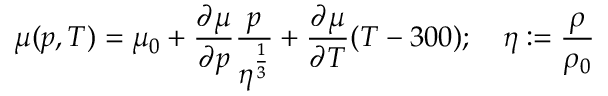<formula> <loc_0><loc_0><loc_500><loc_500>\mu ( p , T ) = \mu _ { 0 } + { \frac { \partial \mu } { \partial p } } { \frac { p } { \eta ^ { \frac { 1 } { 3 } } } } + { \frac { \partial \mu } { \partial T } } ( T - 3 0 0 ) ; \quad \eta \colon = { \frac { \rho } { \rho _ { 0 } } }</formula> 